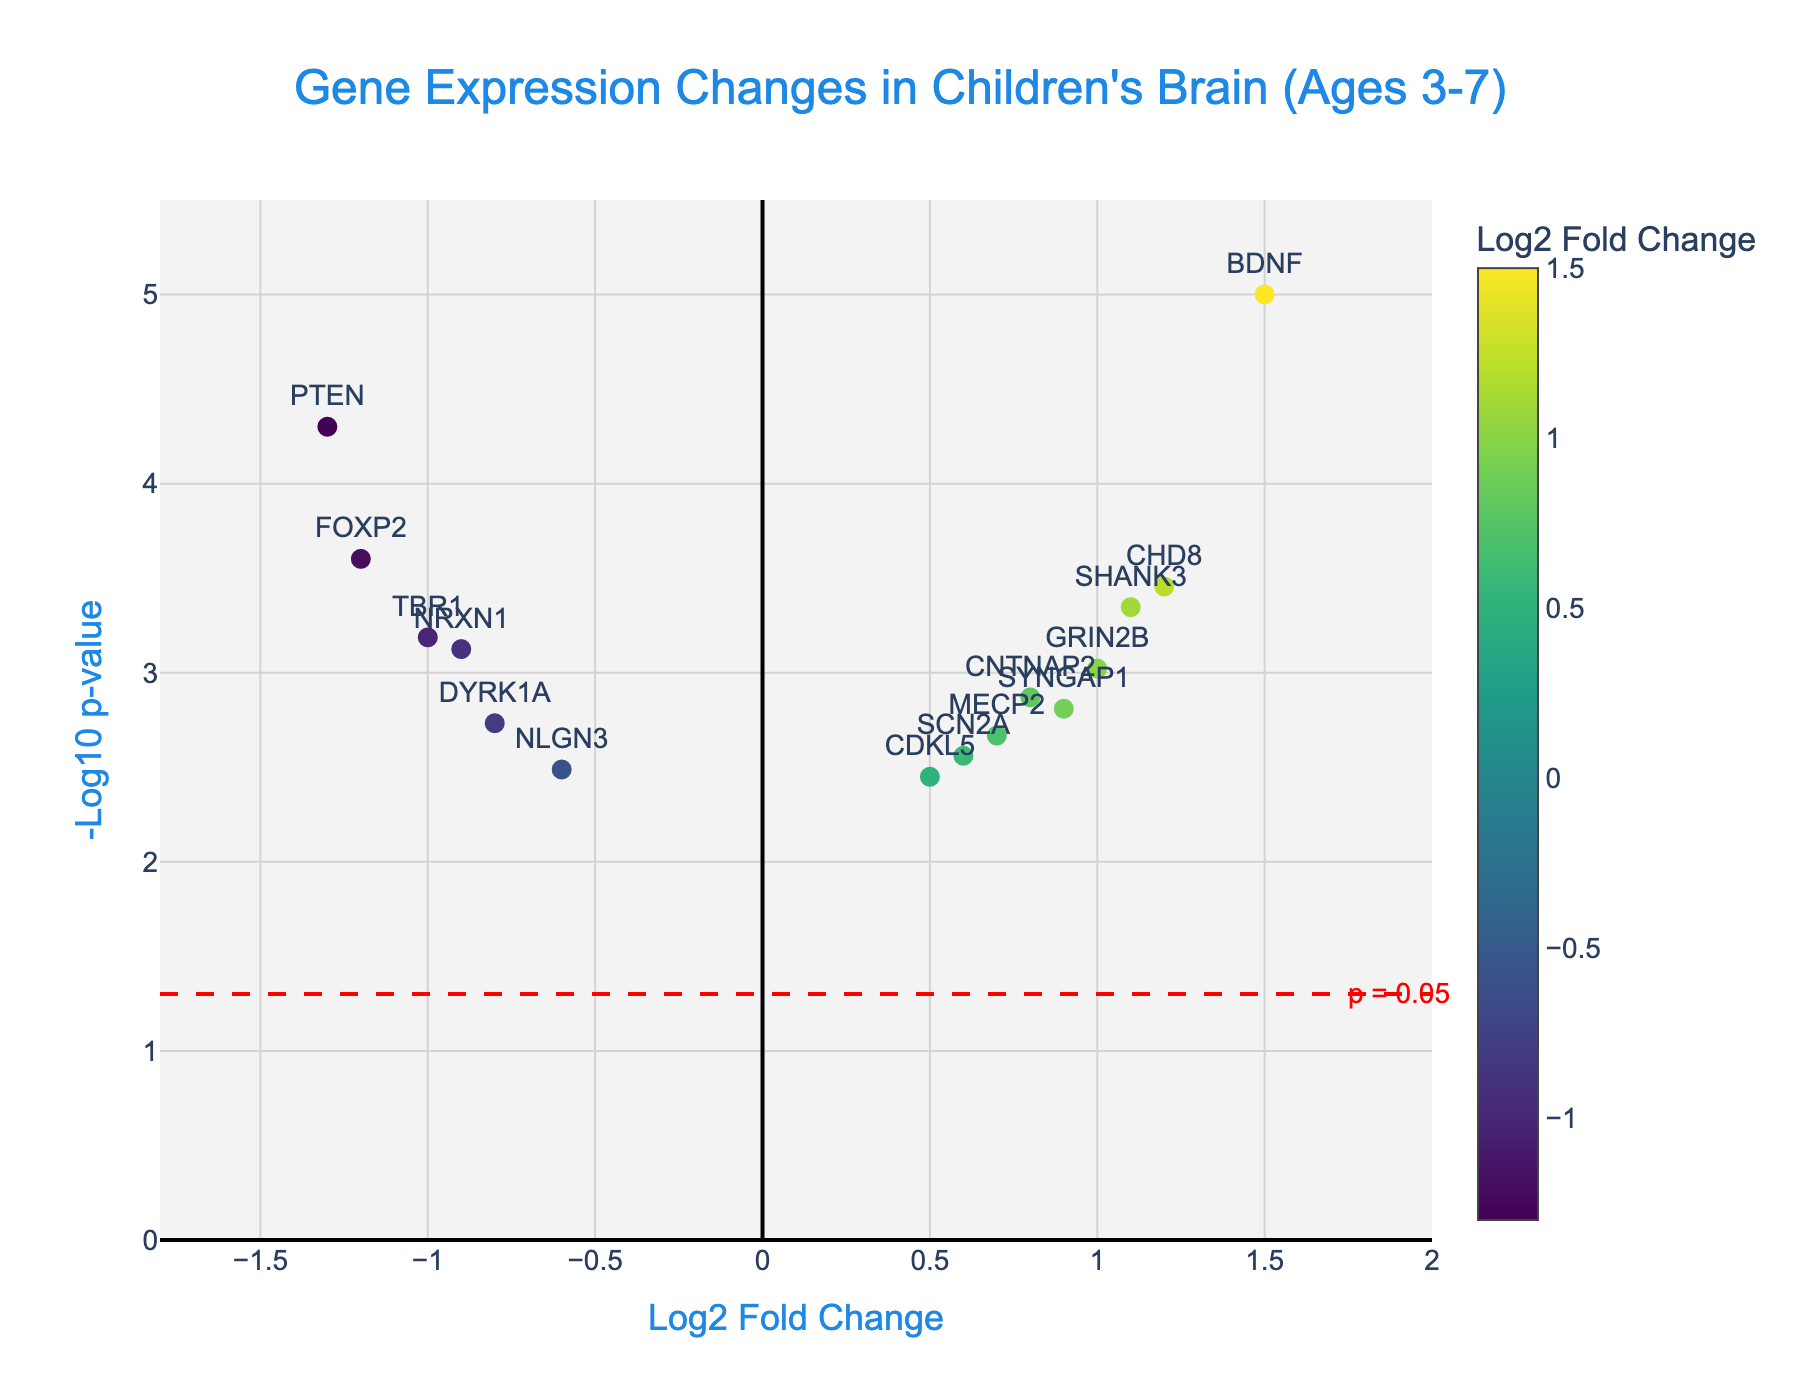What is the title of the plot? The plot title is usually the most prominent text at the top of the figure. It describes what the data represents. In this case, the title is "Gene Expression Changes in Children's Brain (Ages 3-7)".
Answer: Gene Expression Changes in Children's Brain (Ages 3-7) How many genes show a significant change in expression? A significant change in expression is indicated by data points above the red dashed line, which corresponds to a p-value threshold of 0.05. Count the number of data points above this line.
Answer: 15 Which gene has the highest Log2 Fold Change? To find this, look for the data point which is farthest to the right on the x-axis (Log2 Fold Change), and check its label.
Answer: BDNF Which gene has the lowest expression? The gene with the lowest expression will have the most negative Log2 Fold Change value. Look for the data point farthest to the left of the x-axis.
Answer: PTEN Is there any gene with exactly zero Log2 Fold Change? Check if there is any data point exactly on the vertical line at x = 0. There are no such points.
Answer: No What is the p-value threshold indicated by the red dashed line? The horizontal red dashed line represents the p-value threshold. The y-axis value at this line can be transformed back to p-value using -log10; for y = 1.3, the p-value is 0.05.
Answer: p = 0.05 What color represents lower Log2 Fold Change in gene expression? In the color scale on the right, lower Log2 Fold Changes are represented by cooler colors (green) and higher values by warmer colors (yellow).
Answer: Green Which gene is closest to the threshold for significance? Look for the point just above the red dashed line indicating the p-value threshold. It is close and still above the red line.
Answer: SYNGAP1 